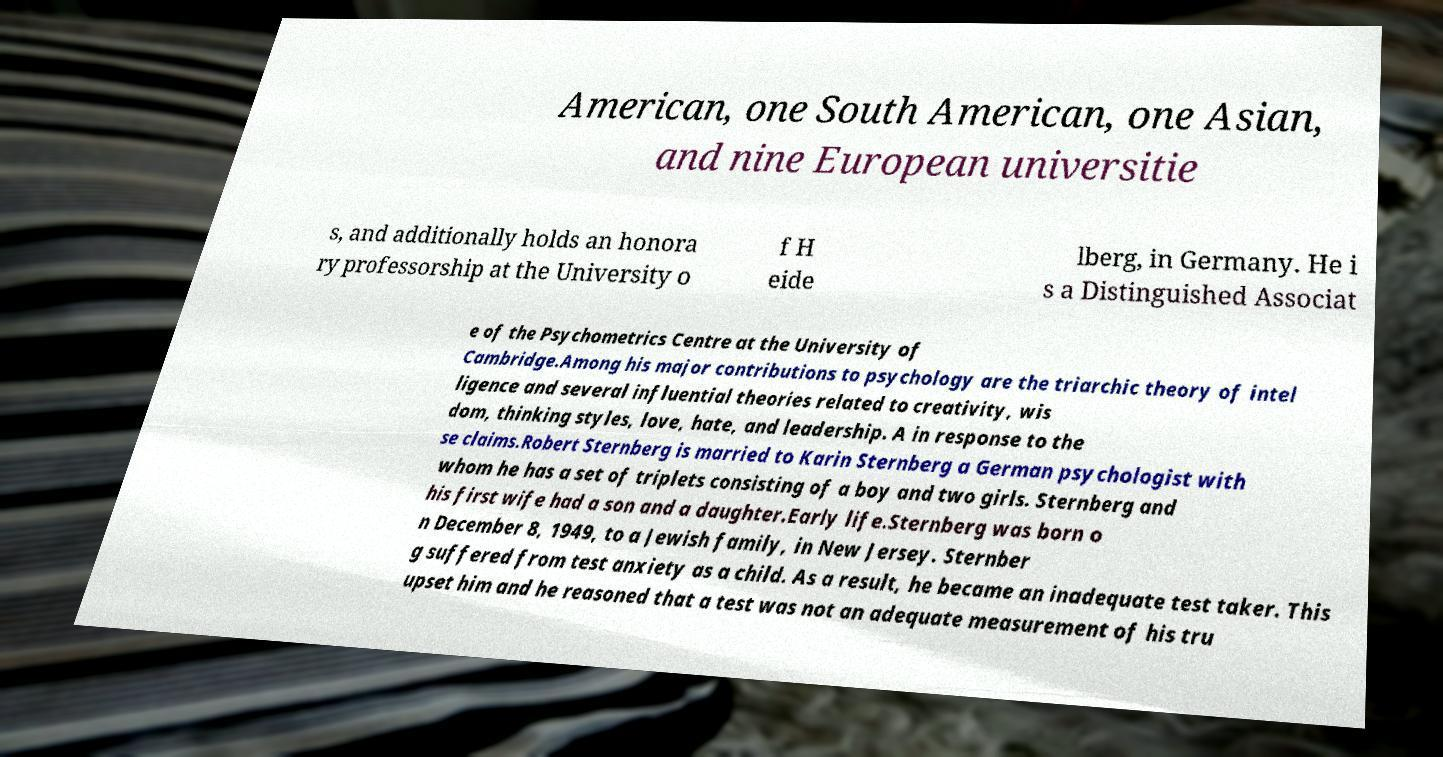For documentation purposes, I need the text within this image transcribed. Could you provide that? American, one South American, one Asian, and nine European universitie s, and additionally holds an honora ry professorship at the University o f H eide lberg, in Germany. He i s a Distinguished Associat e of the Psychometrics Centre at the University of Cambridge.Among his major contributions to psychology are the triarchic theory of intel ligence and several influential theories related to creativity, wis dom, thinking styles, love, hate, and leadership. A in response to the se claims.Robert Sternberg is married to Karin Sternberg a German psychologist with whom he has a set of triplets consisting of a boy and two girls. Sternberg and his first wife had a son and a daughter.Early life.Sternberg was born o n December 8, 1949, to a Jewish family, in New Jersey. Sternber g suffered from test anxiety as a child. As a result, he became an inadequate test taker. This upset him and he reasoned that a test was not an adequate measurement of his tru 